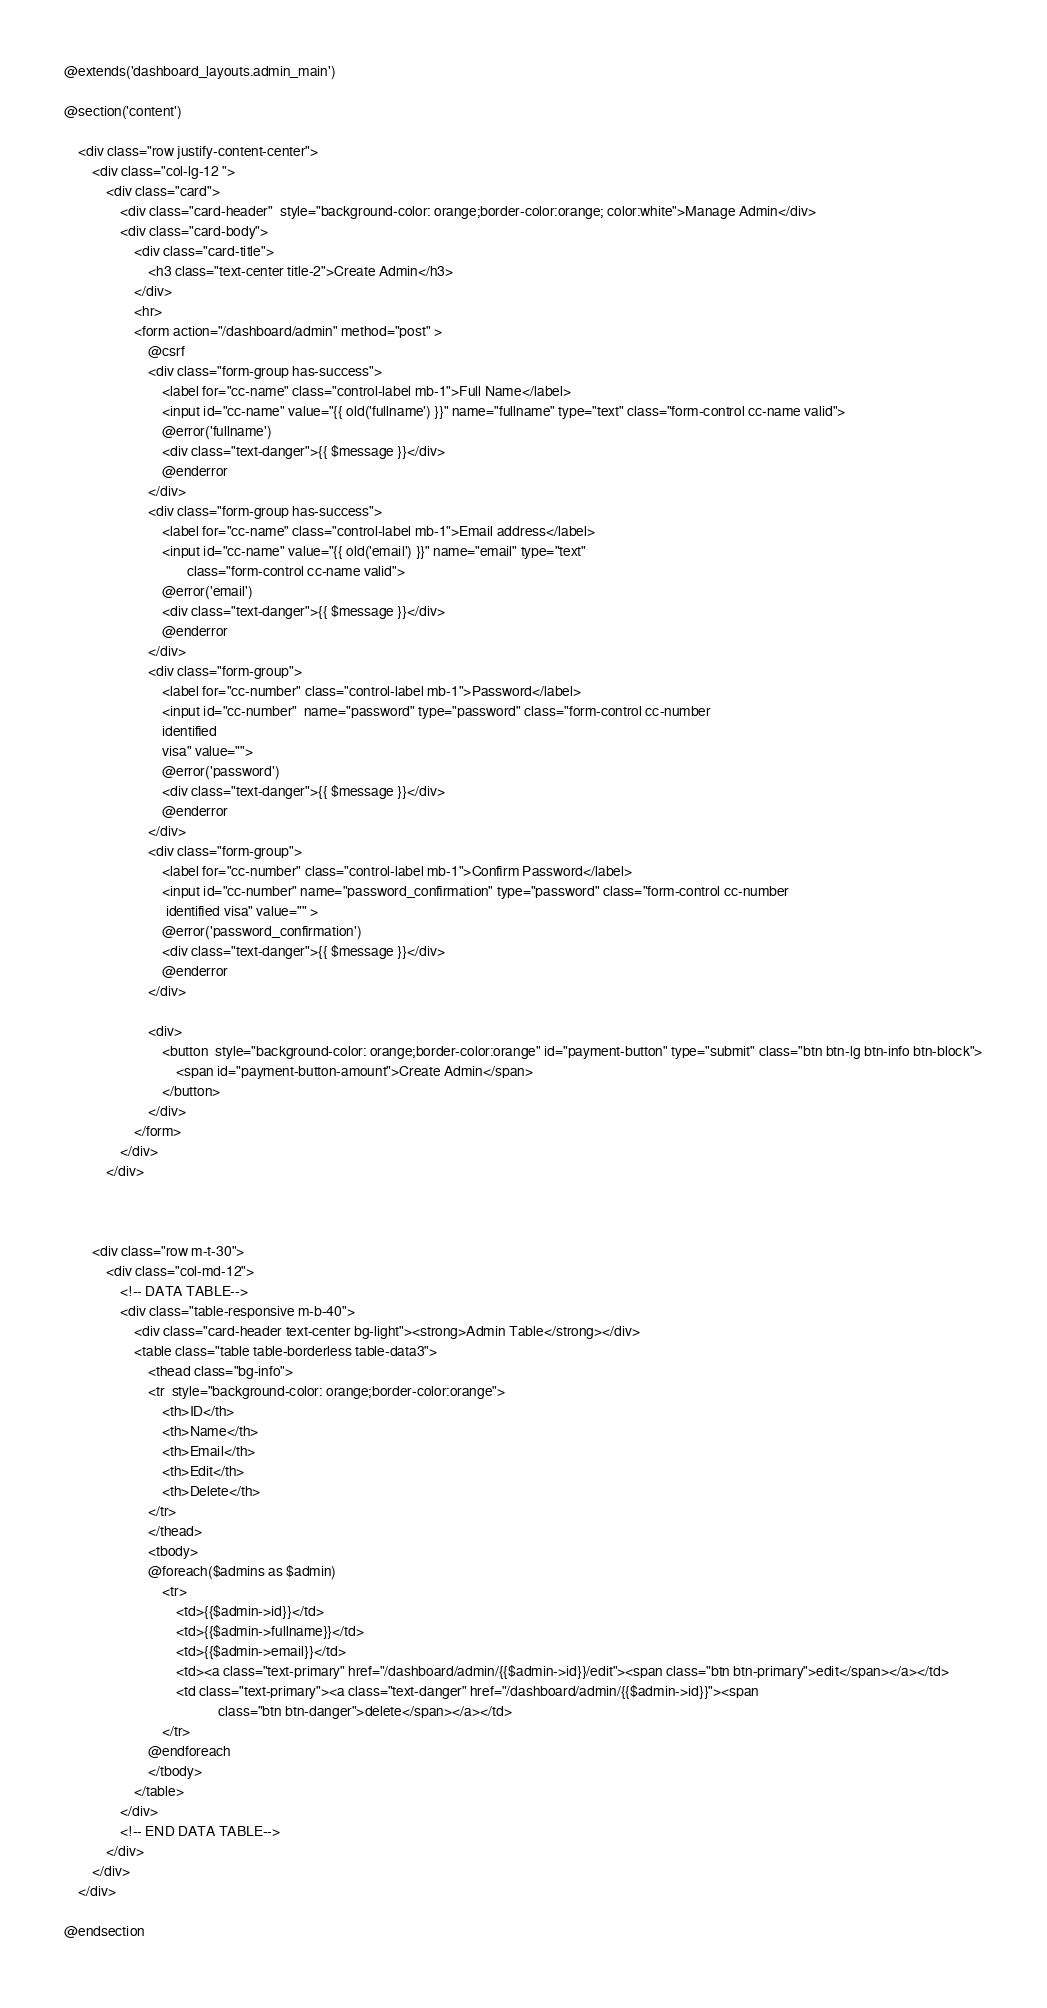Convert code to text. <code><loc_0><loc_0><loc_500><loc_500><_PHP_>@extends('dashboard_layouts.admin_main')

@section('content')

    <div class="row justify-content-center">
        <div class="col-lg-12 ">
            <div class="card">
                <div class="card-header"  style="background-color: orange;border-color:orange; color:white">Manage Admin</div>
                <div class="card-body">
                    <div class="card-title">
                        <h3 class="text-center title-2">Create Admin</h3>
                    </div>
                    <hr>
                    <form action="/dashboard/admin" method="post" >
                        @csrf
                        <div class="form-group has-success">
                            <label for="cc-name" class="control-label mb-1">Full Name</label>
                            <input id="cc-name" value="{{ old('fullname') }}" name="fullname" type="text" class="form-control cc-name valid">
                            @error('fullname')
                            <div class="text-danger">{{ $message }}</div>
                            @enderror
                        </div>
                        <div class="form-group has-success">
                            <label for="cc-name" class="control-label mb-1">Email address</label>
                            <input id="cc-name" value="{{ old('email') }}" name="email" type="text"
                                   class="form-control cc-name valid">
                            @error('email')
                            <div class="text-danger">{{ $message }}</div>
                            @enderror
                        </div>
                        <div class="form-group">
                            <label for="cc-number" class="control-label mb-1">Password</label>
                            <input id="cc-number"  name="password" type="password" class="form-control cc-number
                            identified
                            visa" value="">
                            @error('password')
                            <div class="text-danger">{{ $message }}</div>
                            @enderror
                        </div>
                        <div class="form-group">
                            <label for="cc-number" class="control-label mb-1">Confirm Password</label>
                            <input id="cc-number" name="password_confirmation" type="password" class="form-control cc-number
                             identified visa" value="" >
                            @error('password_confirmation')
                            <div class="text-danger">{{ $message }}</div>
                            @enderror
                        </div>

                        <div>
                            <button  style="background-color: orange;border-color:orange" id="payment-button" type="submit" class="btn btn-lg btn-info btn-block">
                                <span id="payment-button-amount">Create Admin</span>
                            </button>
                        </div>
                    </form>
                </div>
            </div>



        <div class="row m-t-30">
            <div class="col-md-12">
                <!-- DATA TABLE-->
                <div class="table-responsive m-b-40">
                    <div class="card-header text-center bg-light"><strong>Admin Table</strong></div>
                    <table class="table table-borderless table-data3">
                        <thead class="bg-info">
                        <tr  style="background-color: orange;border-color:orange">
                            <th>ID</th>
                            <th>Name</th>
                            <th>Email</th>
                            <th>Edit</th>
                            <th>Delete</th>
                        </tr>
                        </thead>
                        <tbody>
                        @foreach($admins as $admin)
                            <tr>
                                <td>{{$admin->id}}</td>
                                <td>{{$admin->fullname}}</td>
                                <td>{{$admin->email}}</td>
                                <td><a class="text-primary" href="/dashboard/admin/{{$admin->id}}/edit"><span class="btn btn-primary">edit</span></a></td>
                                <td class="text-primary"><a class="text-danger" href="/dashboard/admin/{{$admin->id}}"><span
                                            class="btn btn-danger">delete</span></a></td>
                            </tr>
                        @endforeach
                        </tbody>
                    </table>
                </div>
                <!-- END DATA TABLE-->
            </div>
        </div>
    </div>

@endsection
</code> 